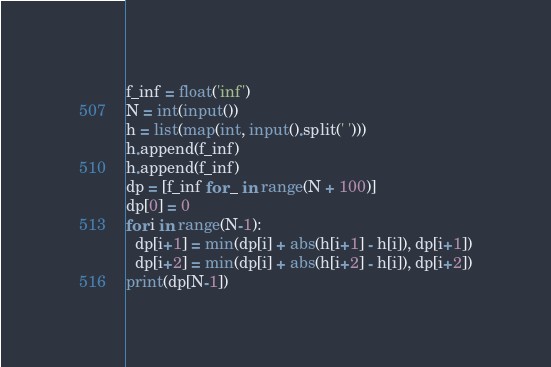Convert code to text. <code><loc_0><loc_0><loc_500><loc_500><_Python_>f_inf = float('inf')
N = int(input())
h = list(map(int, input().split(' ')))
h.append(f_inf)
h.append(f_inf)
dp = [f_inf for _ in range(N + 100)]
dp[0] = 0
for i in range(N-1):
  dp[i+1] = min(dp[i] + abs(h[i+1] - h[i]), dp[i+1])
  dp[i+2] = min(dp[i] + abs(h[i+2] - h[i]), dp[i+2])
print(dp[N-1])</code> 